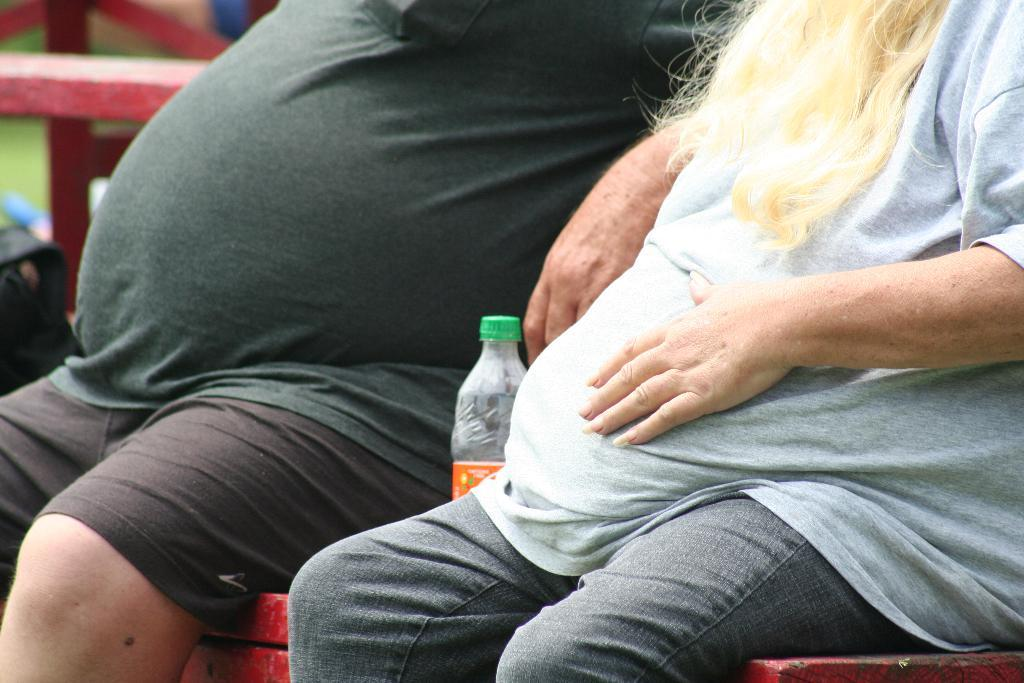How many people are in the image? There are two persons in the image. What are the persons doing in the image? The information provided does not specify what the persons are doing. What color is the surface the persons are sitting on? The persons are sitting on a red surface. What object can be seen in the image besides the persons? There is a bottle visible in the image. What type of ticket is the carpenter holding in the image? There is no carpenter or ticket present in the image. What color is the sweater worn by the person on the left? The information provided does not specify the color of any clothing worn by the persons in the image. 